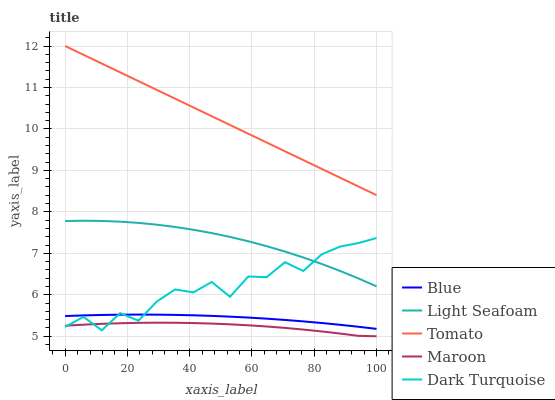Does Maroon have the minimum area under the curve?
Answer yes or no. Yes. Does Tomato have the maximum area under the curve?
Answer yes or no. Yes. Does Light Seafoam have the minimum area under the curve?
Answer yes or no. No. Does Light Seafoam have the maximum area under the curve?
Answer yes or no. No. Is Tomato the smoothest?
Answer yes or no. Yes. Is Dark Turquoise the roughest?
Answer yes or no. Yes. Is Light Seafoam the smoothest?
Answer yes or no. No. Is Light Seafoam the roughest?
Answer yes or no. No. Does Maroon have the lowest value?
Answer yes or no. Yes. Does Light Seafoam have the lowest value?
Answer yes or no. No. Does Tomato have the highest value?
Answer yes or no. Yes. Does Light Seafoam have the highest value?
Answer yes or no. No. Is Blue less than Tomato?
Answer yes or no. Yes. Is Blue greater than Maroon?
Answer yes or no. Yes. Does Blue intersect Dark Turquoise?
Answer yes or no. Yes. Is Blue less than Dark Turquoise?
Answer yes or no. No. Is Blue greater than Dark Turquoise?
Answer yes or no. No. Does Blue intersect Tomato?
Answer yes or no. No. 